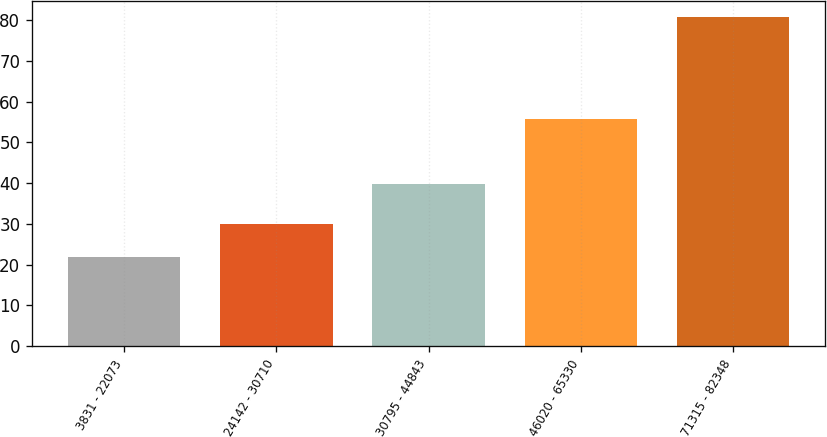Convert chart to OTSL. <chart><loc_0><loc_0><loc_500><loc_500><bar_chart><fcel>3831 - 22073<fcel>24142 - 30710<fcel>30795 - 44843<fcel>46020 - 65330<fcel>71315 - 82348<nl><fcel>21.98<fcel>30.09<fcel>39.8<fcel>55.74<fcel>80.71<nl></chart> 